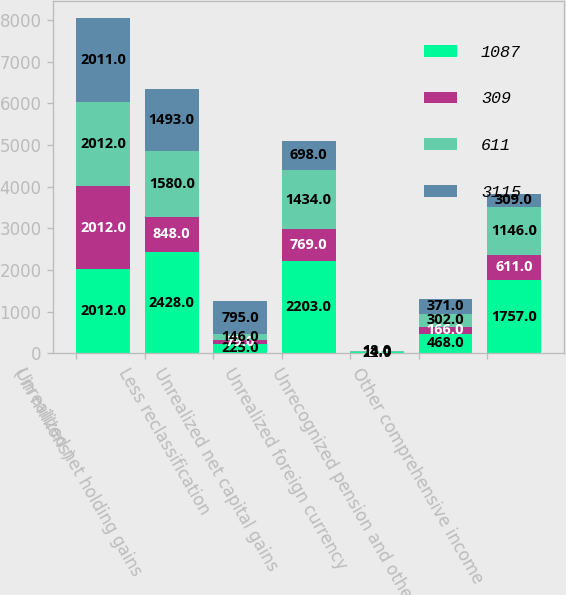<chart> <loc_0><loc_0><loc_500><loc_500><stacked_bar_chart><ecel><fcel>( in millions)<fcel>Unrealized net holding gains<fcel>Less reclassification<fcel>Unrealized net capital gains<fcel>Unrealized foreign currency<fcel>Unrecognized pension and other<fcel>Other comprehensive income<nl><fcel>1087<fcel>2012<fcel>2428<fcel>225<fcel>2203<fcel>22<fcel>468<fcel>1757<nl><fcel>309<fcel>2012<fcel>848<fcel>79<fcel>769<fcel>8<fcel>166<fcel>611<nl><fcel>611<fcel>2012<fcel>1580<fcel>146<fcel>1434<fcel>14<fcel>302<fcel>1146<nl><fcel>3115<fcel>2011<fcel>1493<fcel>795<fcel>698<fcel>18<fcel>371<fcel>309<nl></chart> 